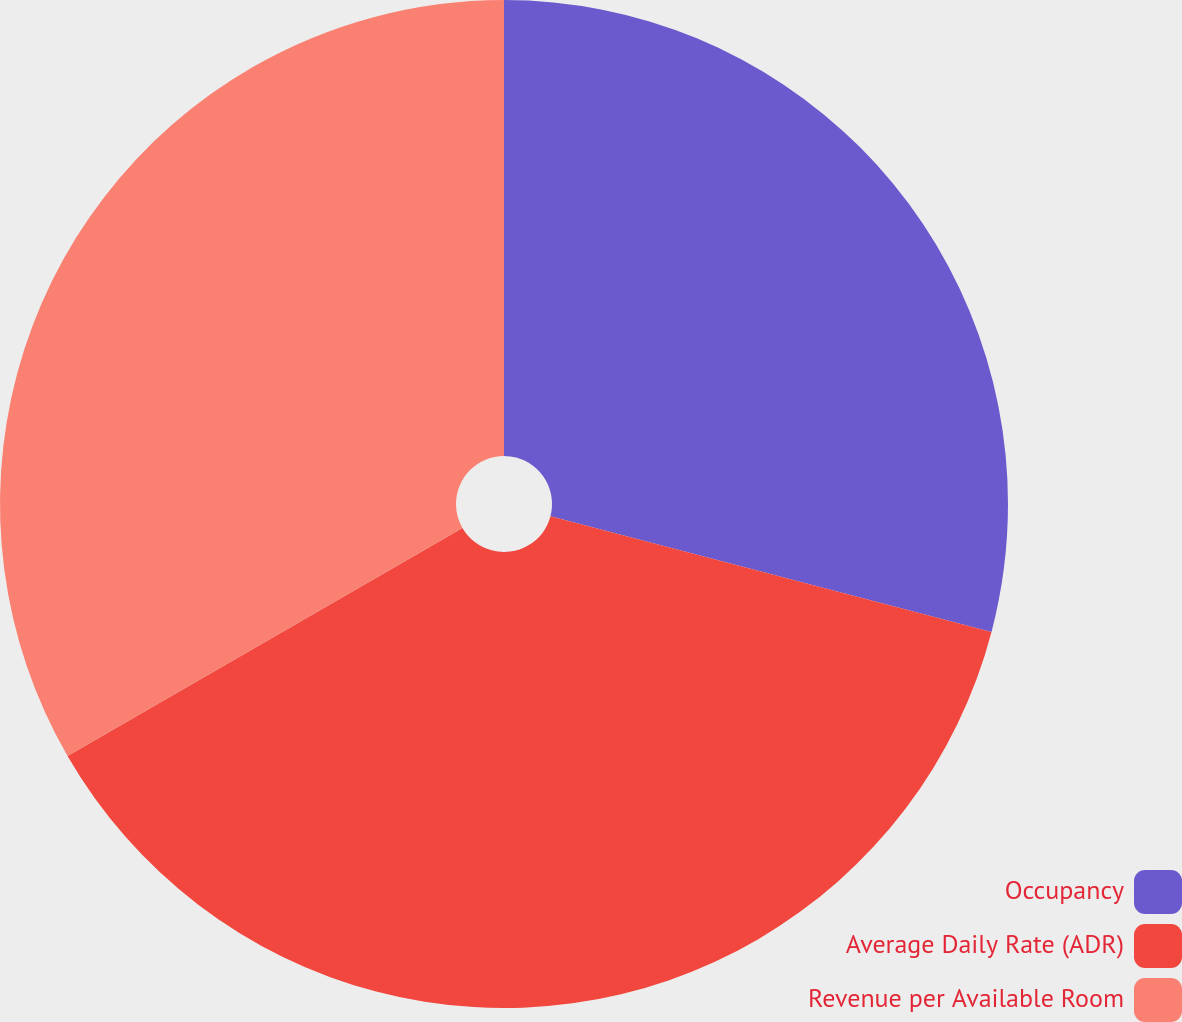Convert chart. <chart><loc_0><loc_0><loc_500><loc_500><pie_chart><fcel>Occupancy<fcel>Average Daily Rate (ADR)<fcel>Revenue per Available Room<nl><fcel>29.08%<fcel>37.58%<fcel>33.33%<nl></chart> 